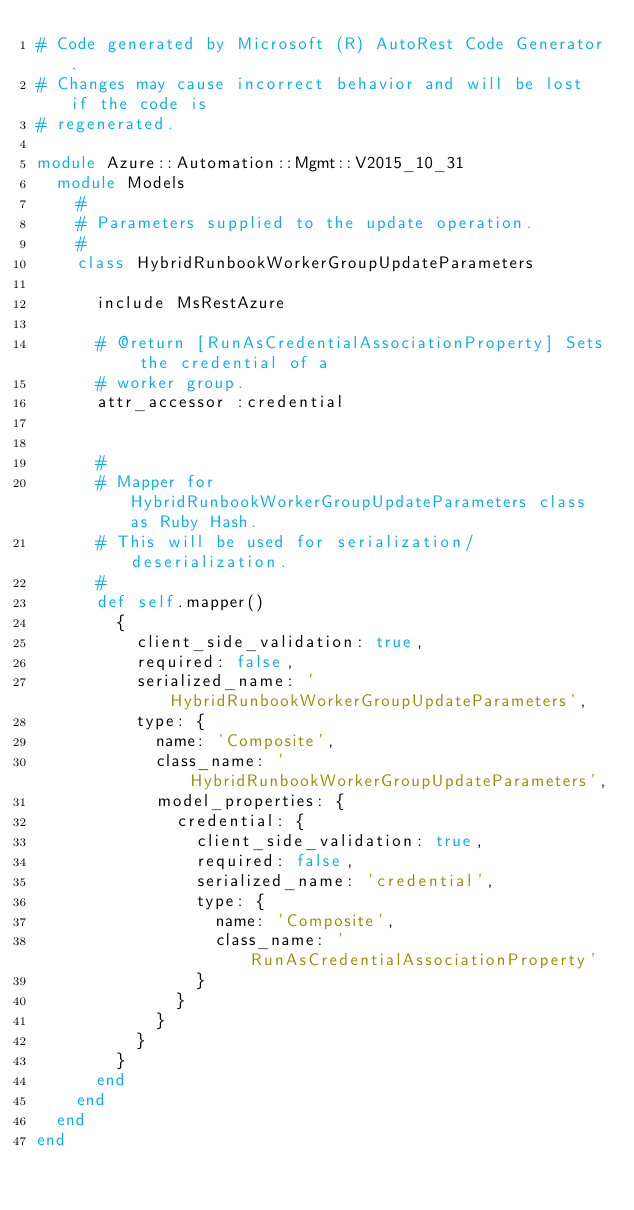Convert code to text. <code><loc_0><loc_0><loc_500><loc_500><_Ruby_># Code generated by Microsoft (R) AutoRest Code Generator.
# Changes may cause incorrect behavior and will be lost if the code is
# regenerated.

module Azure::Automation::Mgmt::V2015_10_31
  module Models
    #
    # Parameters supplied to the update operation.
    #
    class HybridRunbookWorkerGroupUpdateParameters

      include MsRestAzure

      # @return [RunAsCredentialAssociationProperty] Sets the credential of a
      # worker group.
      attr_accessor :credential


      #
      # Mapper for HybridRunbookWorkerGroupUpdateParameters class as Ruby Hash.
      # This will be used for serialization/deserialization.
      #
      def self.mapper()
        {
          client_side_validation: true,
          required: false,
          serialized_name: 'HybridRunbookWorkerGroupUpdateParameters',
          type: {
            name: 'Composite',
            class_name: 'HybridRunbookWorkerGroupUpdateParameters',
            model_properties: {
              credential: {
                client_side_validation: true,
                required: false,
                serialized_name: 'credential',
                type: {
                  name: 'Composite',
                  class_name: 'RunAsCredentialAssociationProperty'
                }
              }
            }
          }
        }
      end
    end
  end
end
</code> 